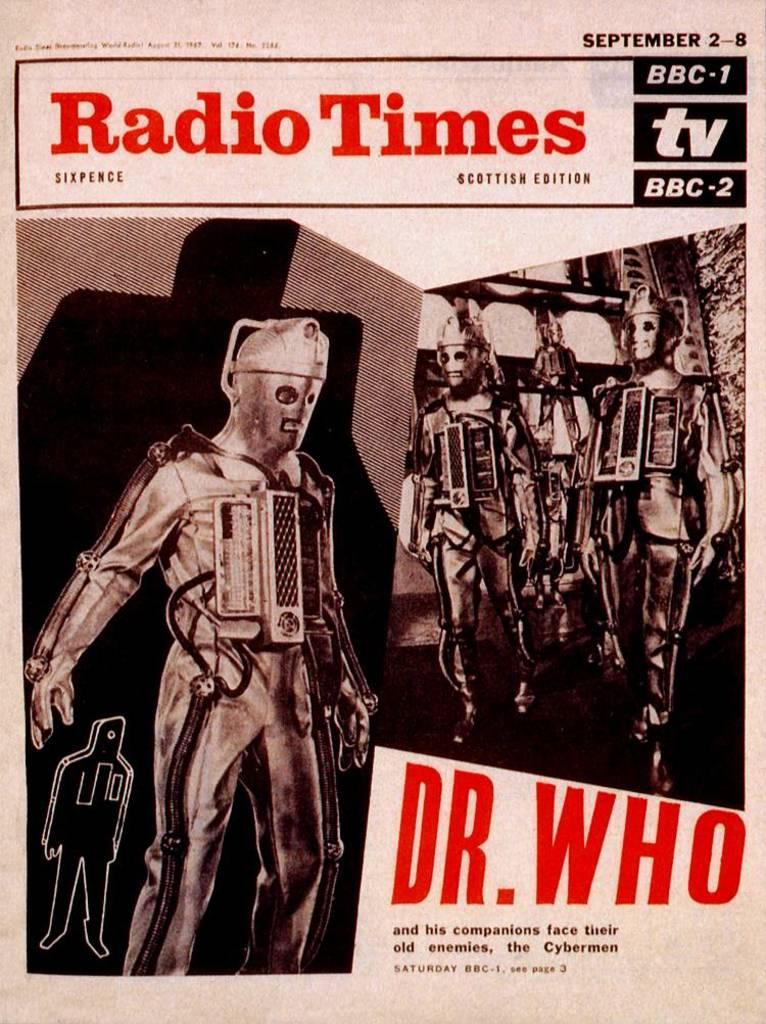Provide a one-sentence caption for the provided image. Dr Who and his companions are on the cover of Radio Times. 